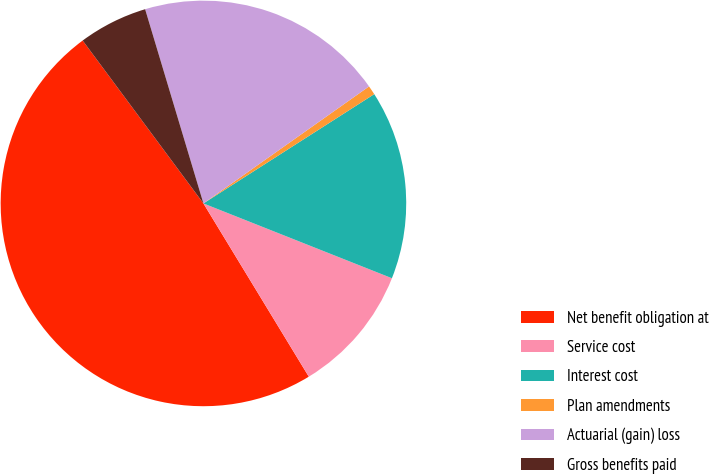Convert chart. <chart><loc_0><loc_0><loc_500><loc_500><pie_chart><fcel>Net benefit obligation at<fcel>Service cost<fcel>Interest cost<fcel>Plan amendments<fcel>Actuarial (gain) loss<fcel>Gross benefits paid<nl><fcel>48.54%<fcel>10.29%<fcel>15.07%<fcel>0.73%<fcel>19.85%<fcel>5.51%<nl></chart> 